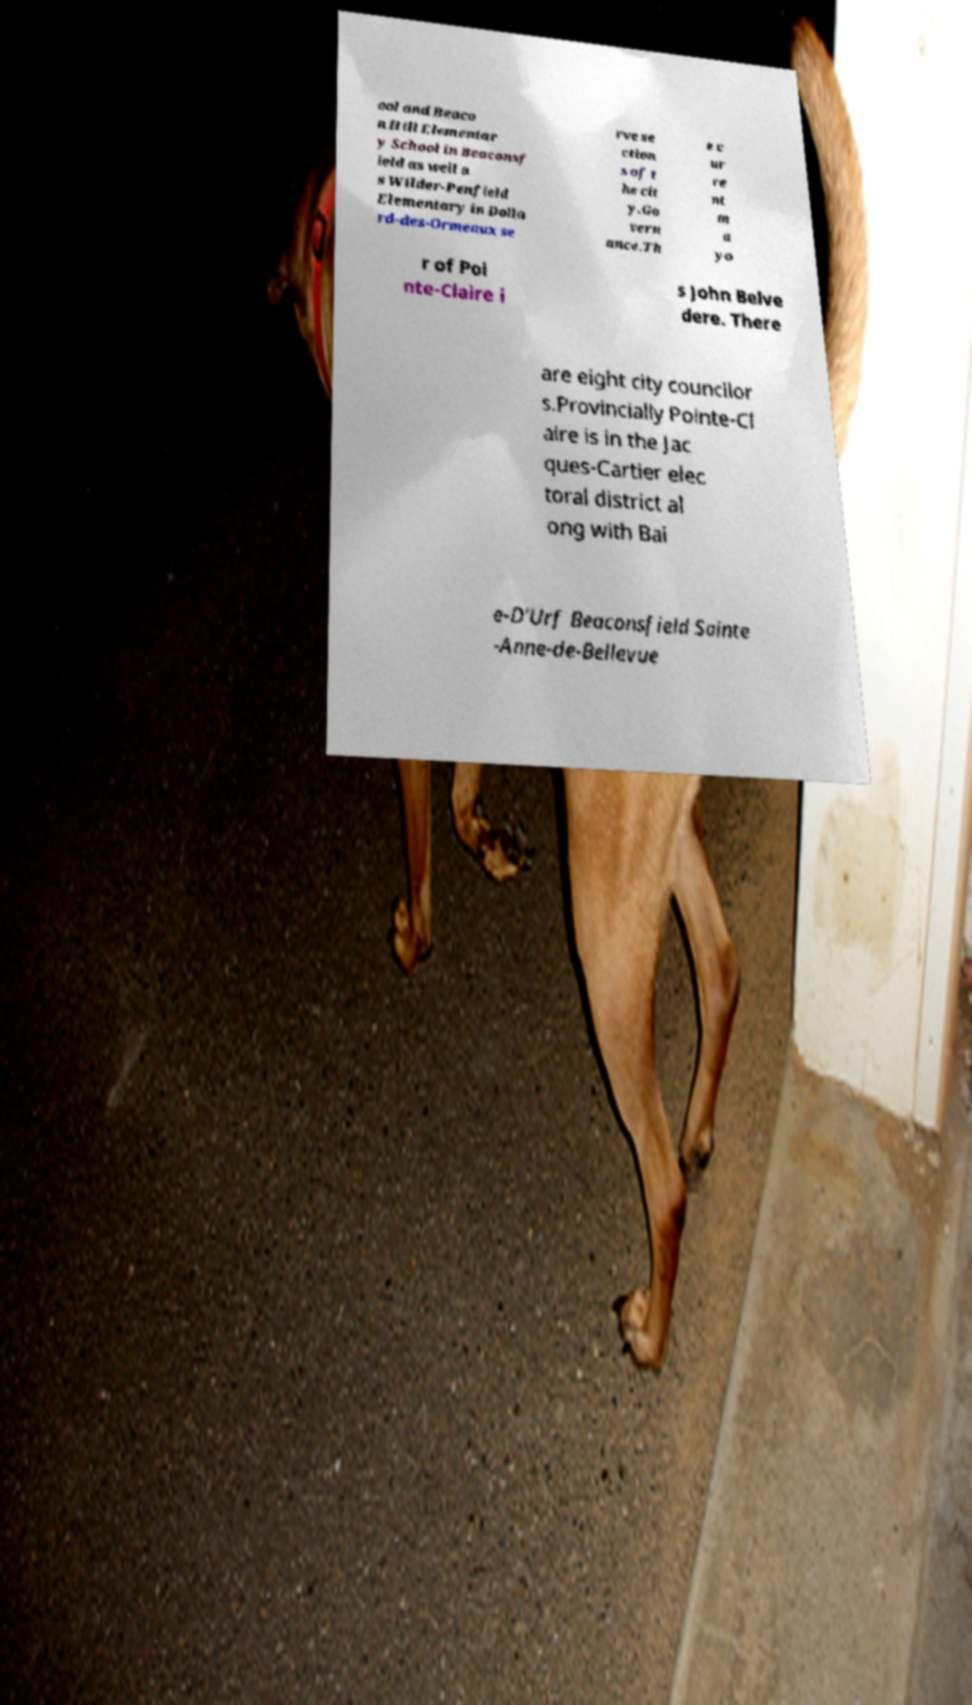Can you read and provide the text displayed in the image?This photo seems to have some interesting text. Can you extract and type it out for me? ool and Beaco n Hill Elementar y School in Beaconsf ield as well a s Wilder-Penfield Elementary in Dolla rd-des-Ormeaux se rve se ction s of t he cit y.Go vern ance.Th e c ur re nt m a yo r of Poi nte-Claire i s John Belve dere. There are eight city councilor s.Provincially Pointe-Cl aire is in the Jac ques-Cartier elec toral district al ong with Bai e-D'Urf Beaconsfield Sainte -Anne-de-Bellevue 